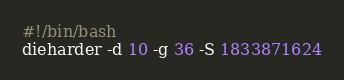<code> <loc_0><loc_0><loc_500><loc_500><_Bash_>#!/bin/bash
dieharder -d 10 -g 36 -S 1833871624
</code> 